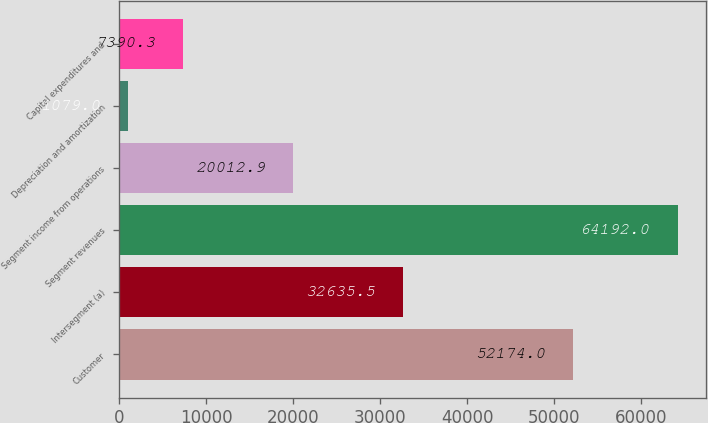<chart> <loc_0><loc_0><loc_500><loc_500><bar_chart><fcel>Customer<fcel>Intersegment (a)<fcel>Segment revenues<fcel>Segment income from operations<fcel>Depreciation and amortization<fcel>Capital expenditures and<nl><fcel>52174<fcel>32635.5<fcel>64192<fcel>20012.9<fcel>1079<fcel>7390.3<nl></chart> 